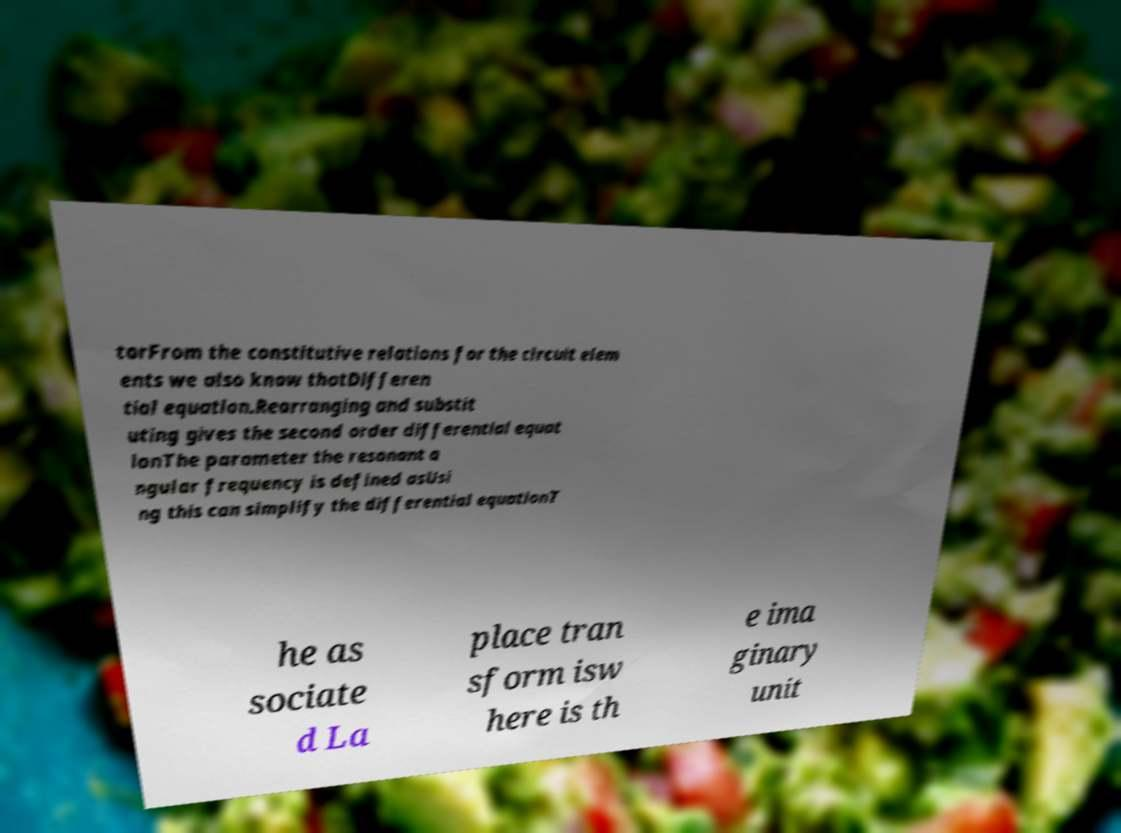Could you assist in decoding the text presented in this image and type it out clearly? torFrom the constitutive relations for the circuit elem ents we also know thatDifferen tial equation.Rearranging and substit uting gives the second order differential equat ionThe parameter the resonant a ngular frequency is defined asUsi ng this can simplify the differential equationT he as sociate d La place tran sform isw here is th e ima ginary unit 